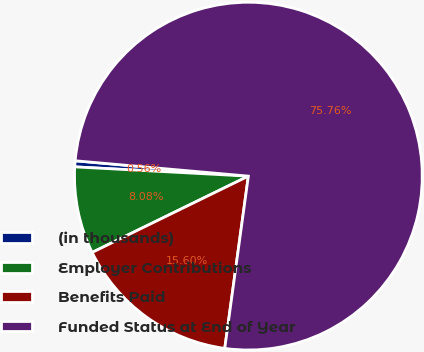Convert chart. <chart><loc_0><loc_0><loc_500><loc_500><pie_chart><fcel>(in thousands)<fcel>Employer Contributions<fcel>Benefits Paid<fcel>Funded Status at End of Year<nl><fcel>0.56%<fcel>8.08%<fcel>15.6%<fcel>75.76%<nl></chart> 